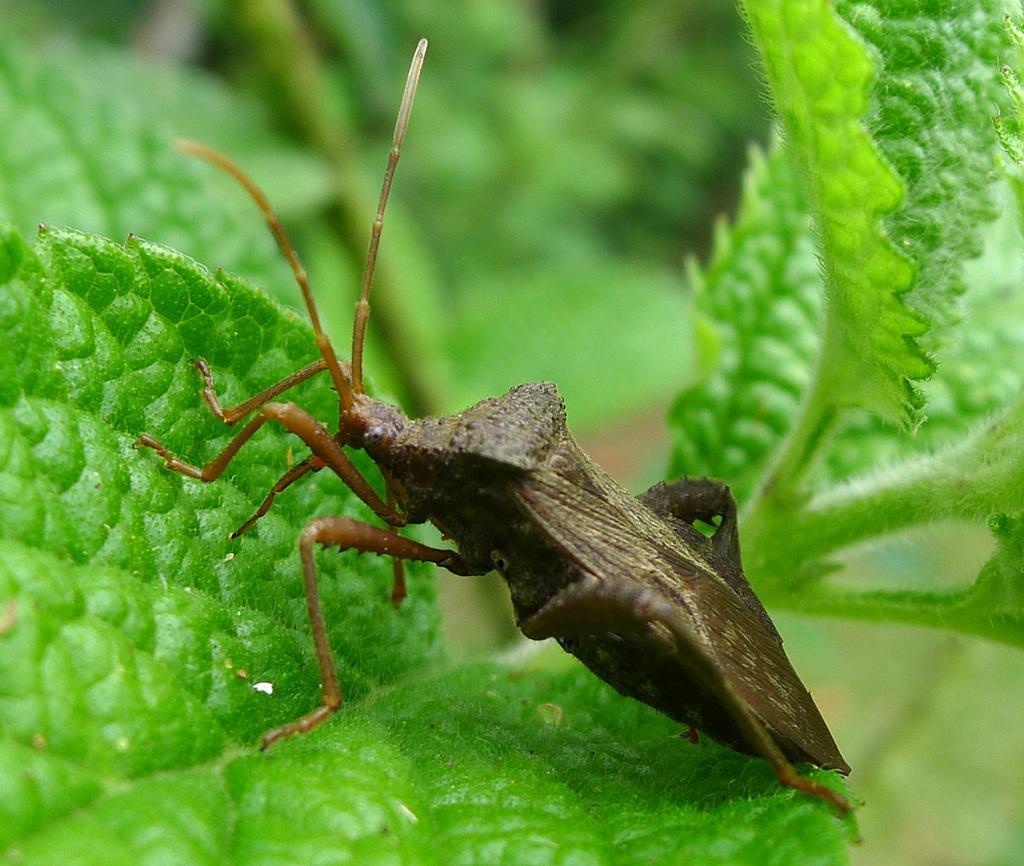Could you give a brief overview of what you see in this image? In the image there is an insect on the leaves. 